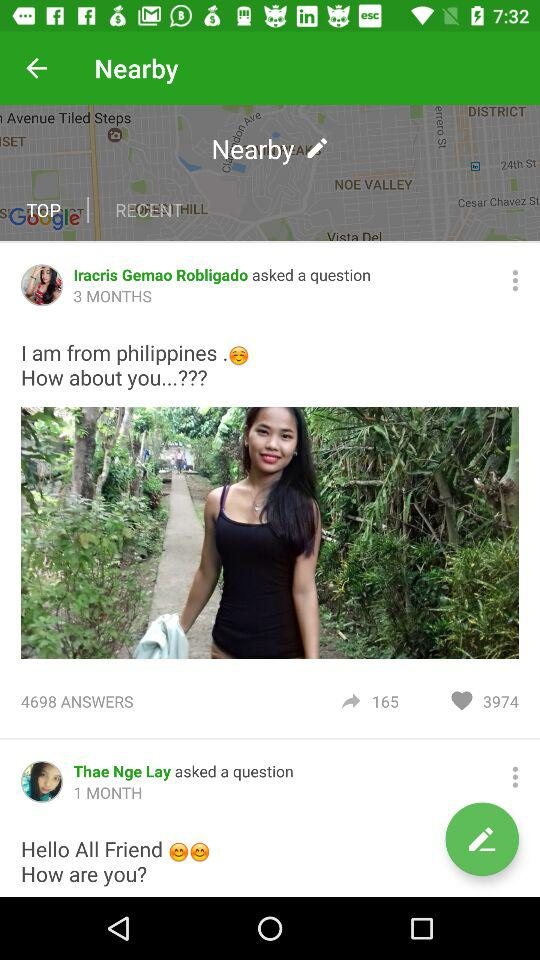How many likes does Iracris Gemao Robligado receive? Iracris Gemao Robligado received 3974 likes. 